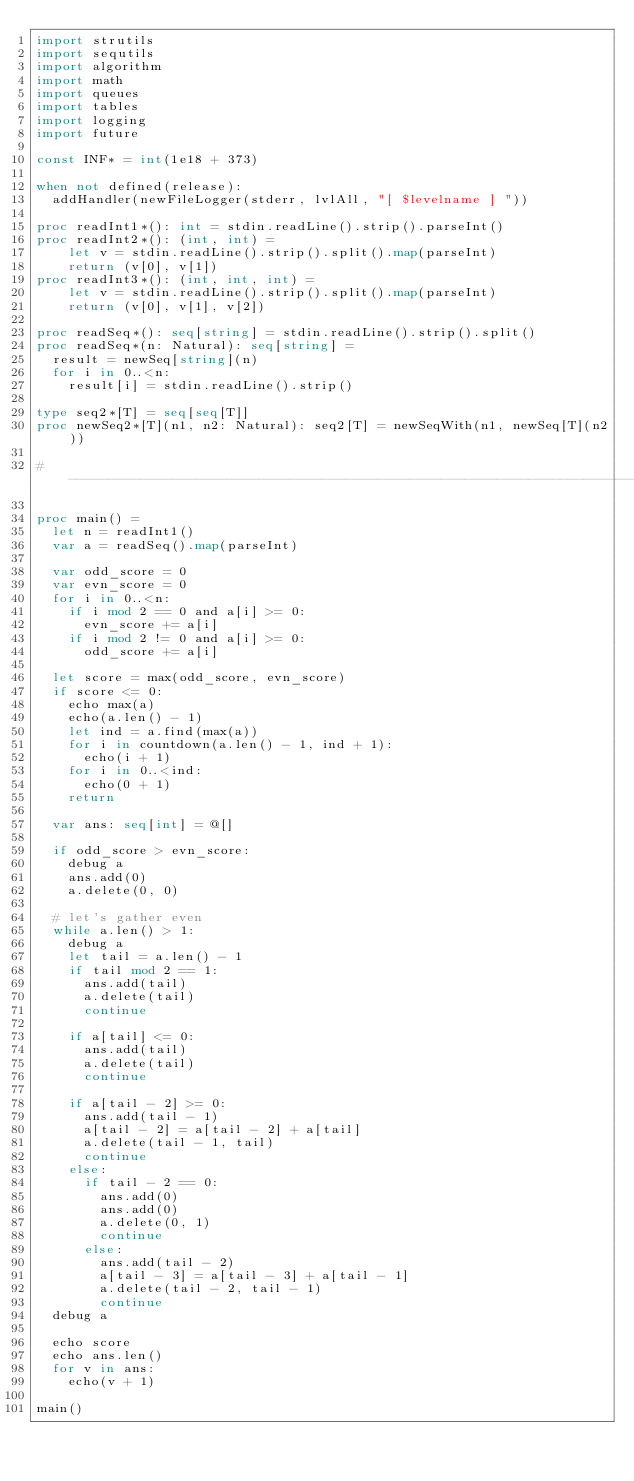<code> <loc_0><loc_0><loc_500><loc_500><_Nim_>import strutils
import sequtils
import algorithm
import math
import queues
import tables
import logging
import future

const INF* = int(1e18 + 373)

when not defined(release):
  addHandler(newFileLogger(stderr, lvlAll, "[ $levelname ] "))

proc readInt1*(): int = stdin.readLine().strip().parseInt()
proc readInt2*(): (int, int) =
    let v = stdin.readLine().strip().split().map(parseInt)
    return (v[0], v[1])
proc readInt3*(): (int, int, int) =
    let v = stdin.readLine().strip().split().map(parseInt)
    return (v[0], v[1], v[2])

proc readSeq*(): seq[string] = stdin.readLine().strip().split()
proc readSeq*(n: Natural): seq[string] =
  result = newSeq[string](n)
  for i in 0..<n:
    result[i] = stdin.readLine().strip()

type seq2*[T] = seq[seq[T]]
proc newSeq2*[T](n1, n2: Natural): seq2[T] = newSeqWith(n1, newSeq[T](n2))

#------------------------------------------------------------------------------#

proc main() =
  let n = readInt1()
  var a = readSeq().map(parseInt)

  var odd_score = 0
  var evn_score = 0
  for i in 0..<n:
    if i mod 2 == 0 and a[i] >= 0:
      evn_score += a[i]
    if i mod 2 != 0 and a[i] >= 0:
      odd_score += a[i]

  let score = max(odd_score, evn_score)
  if score <= 0:
    echo max(a)
    echo(a.len() - 1)
    let ind = a.find(max(a))
    for i in countdown(a.len() - 1, ind + 1):
      echo(i + 1)
    for i in 0..<ind:
      echo(0 + 1)
    return

  var ans: seq[int] = @[]

  if odd_score > evn_score:
    debug a
    ans.add(0)
    a.delete(0, 0)

  # let's gather even
  while a.len() > 1:
    debug a
    let tail = a.len() - 1
    if tail mod 2 == 1:
      ans.add(tail)
      a.delete(tail)
      continue

    if a[tail] <= 0:
      ans.add(tail)
      a.delete(tail)
      continue

    if a[tail - 2] >= 0:
      ans.add(tail - 1)
      a[tail - 2] = a[tail - 2] + a[tail]
      a.delete(tail - 1, tail)
      continue
    else:
      if tail - 2 == 0:
        ans.add(0)
        ans.add(0)
        a.delete(0, 1)
        continue
      else:
        ans.add(tail - 2)
        a[tail - 3] = a[tail - 3] + a[tail - 1]
        a.delete(tail - 2, tail - 1)
        continue
  debug a

  echo score
  echo ans.len()
  for v in ans:
    echo(v + 1)

main()

</code> 